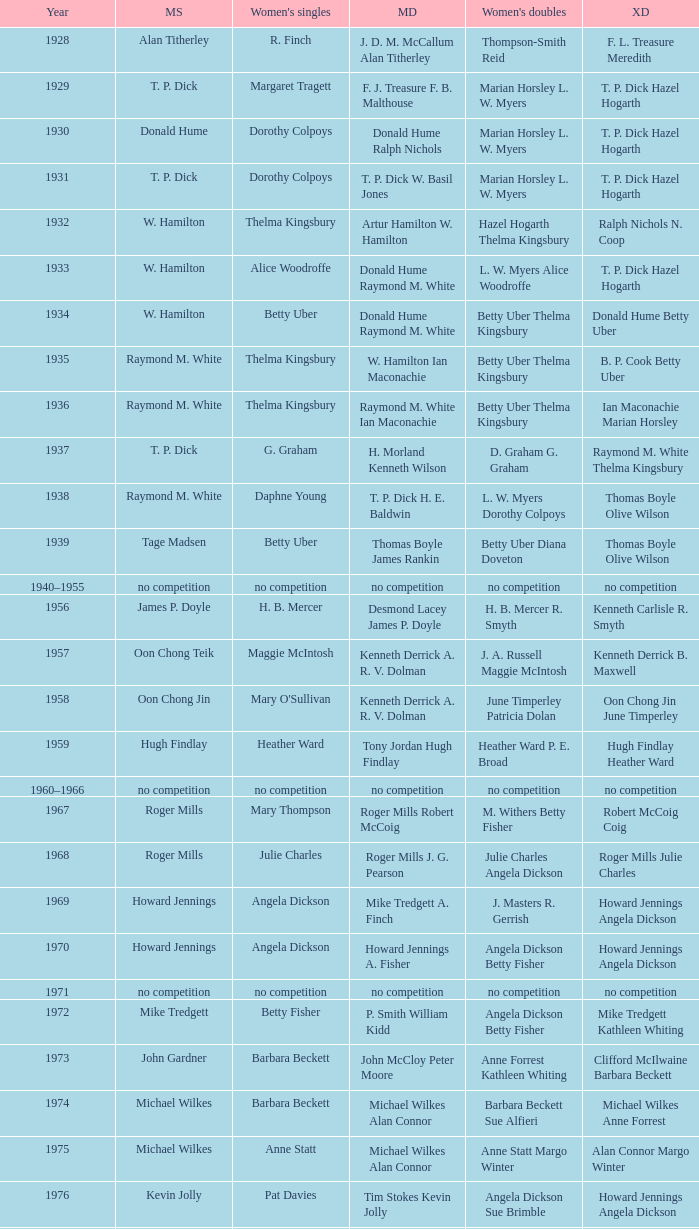Who won the Women's doubles in the year that Jesper Knudsen Nettie Nielsen won the Mixed doubles? Karen Beckman Sara Halsall. 